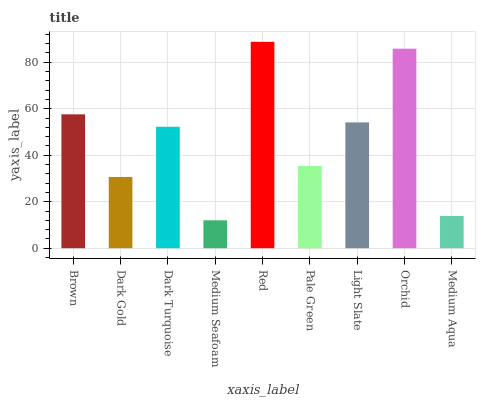Is Medium Seafoam the minimum?
Answer yes or no. Yes. Is Red the maximum?
Answer yes or no. Yes. Is Dark Gold the minimum?
Answer yes or no. No. Is Dark Gold the maximum?
Answer yes or no. No. Is Brown greater than Dark Gold?
Answer yes or no. Yes. Is Dark Gold less than Brown?
Answer yes or no. Yes. Is Dark Gold greater than Brown?
Answer yes or no. No. Is Brown less than Dark Gold?
Answer yes or no. No. Is Dark Turquoise the high median?
Answer yes or no. Yes. Is Dark Turquoise the low median?
Answer yes or no. Yes. Is Medium Aqua the high median?
Answer yes or no. No. Is Medium Seafoam the low median?
Answer yes or no. No. 